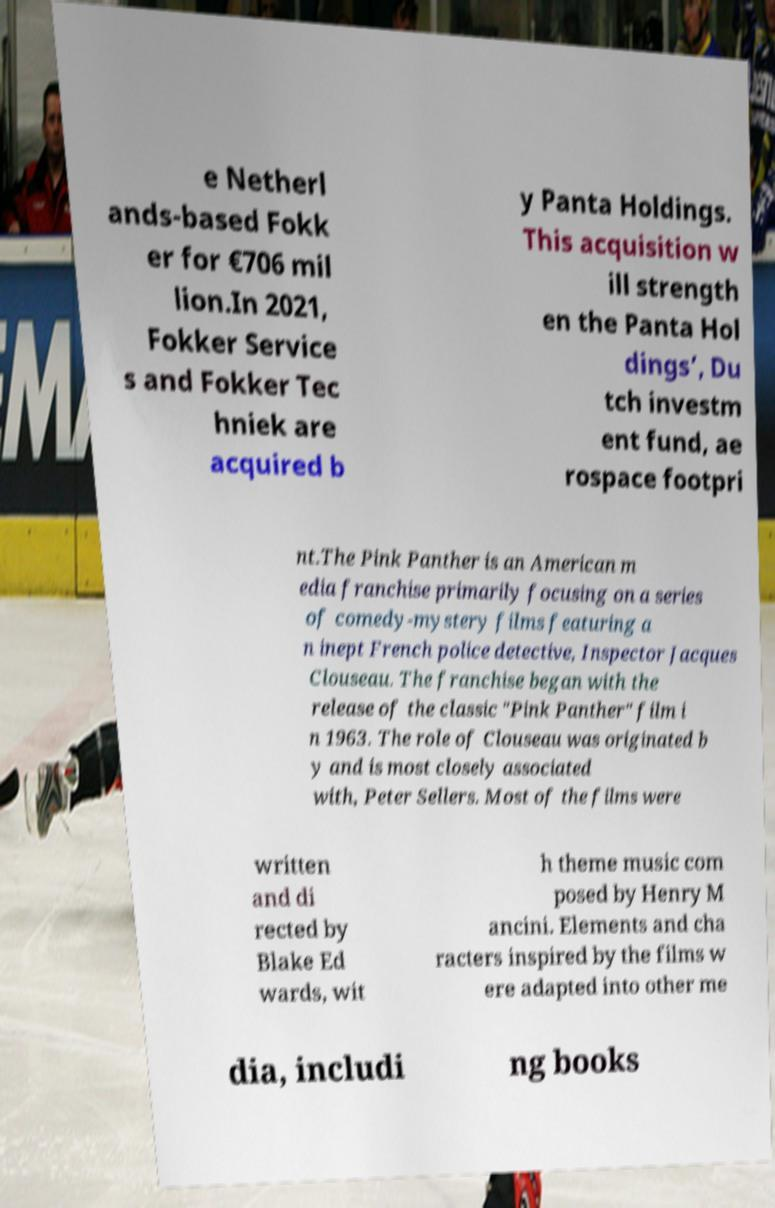I need the written content from this picture converted into text. Can you do that? e Netherl ands-based Fokk er for €706 mil lion.In 2021, Fokker Service s and Fokker Tec hniek are acquired b y Panta Holdings. This acquisition w ill strength en the Panta Hol dings’, Du tch investm ent fund, ae rospace footpri nt.The Pink Panther is an American m edia franchise primarily focusing on a series of comedy-mystery films featuring a n inept French police detective, Inspector Jacques Clouseau. The franchise began with the release of the classic "Pink Panther" film i n 1963. The role of Clouseau was originated b y and is most closely associated with, Peter Sellers. Most of the films were written and di rected by Blake Ed wards, wit h theme music com posed by Henry M ancini. Elements and cha racters inspired by the films w ere adapted into other me dia, includi ng books 